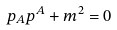Convert formula to latex. <formula><loc_0><loc_0><loc_500><loc_500>p _ { A } p ^ { A } + m ^ { 2 } = 0</formula> 